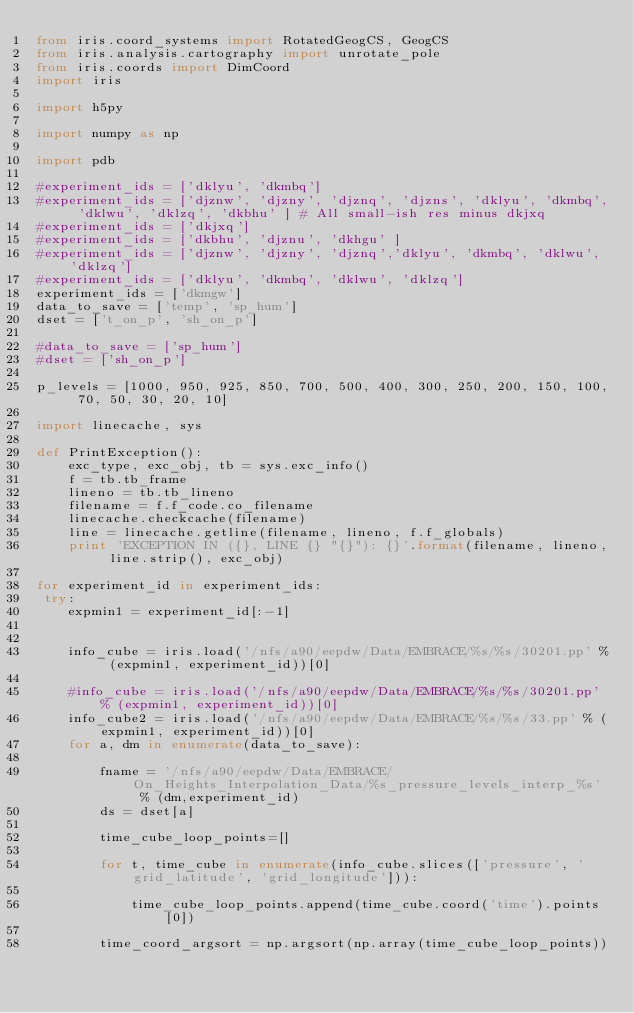<code> <loc_0><loc_0><loc_500><loc_500><_Python_>from iris.coord_systems import RotatedGeogCS, GeogCS
from iris.analysis.cartography import unrotate_pole
from iris.coords import DimCoord
import iris

import h5py

import numpy as np

import pdb

#experiment_ids = ['dklyu', 'dkmbq']
#experiment_ids = ['djznw', 'djzny', 'djznq', 'djzns', 'dklyu', 'dkmbq', 'dklwu', 'dklzq', 'dkbhu' ] # All small-ish res minus dkjxq
#experiment_ids = ['dkjxq']
#experiment_ids = ['dkbhu', 'djznu', 'dkhgu' ]
#experiment_ids = ['djznw', 'djzny', 'djznq','dklyu', 'dkmbq', 'dklwu', 'dklzq']
#experiment_ids = ['dklyu', 'dkmbq', 'dklwu', 'dklzq']
experiment_ids = ['dkmgw']
data_to_save = ['temp', 'sp_hum']
dset = ['t_on_p', 'sh_on_p']

#data_to_save = ['sp_hum']
#dset = ['sh_on_p']

p_levels = [1000, 950, 925, 850, 700, 500, 400, 300, 250, 200, 150, 100, 70, 50, 30, 20, 10]

import linecache, sys

def PrintException():
    exc_type, exc_obj, tb = sys.exc_info()
    f = tb.tb_frame
    lineno = tb.tb_lineno
    filename = f.f_code.co_filename
    linecache.checkcache(filename)
    line = linecache.getline(filename, lineno, f.f_globals)
    print 'EXCEPTION IN ({}, LINE {} "{}"): {}'.format(filename, lineno, line.strip(), exc_obj)

for experiment_id in experiment_ids:
 try:
    expmin1 = experiment_id[:-1]

   
    info_cube = iris.load('/nfs/a90/eepdw/Data/EMBRACE/%s/%s/30201.pp' % (expmin1, experiment_id))[0]

    #info_cube = iris.load('/nfs/a90/eepdw/Data/EMBRACE/%s/%s/30201.pp' % (expmin1, experiment_id))[0]
    info_cube2 = iris.load('/nfs/a90/eepdw/Data/EMBRACE/%s/%s/33.pp' % (expmin1, experiment_id))[0]
    for a, dm in enumerate(data_to_save):
    
        fname = '/nfs/a90/eepdw/Data/EMBRACE/On_Heights_Interpolation_Data/%s_pressure_levels_interp_%s' % (dm,experiment_id)
        ds = dset[a]

        time_cube_loop_points=[]

        for t, time_cube in enumerate(info_cube.slices(['pressure', 'grid_latitude', 'grid_longitude'])):
      
            time_cube_loop_points.append(time_cube.coord('time').points[0])

        time_coord_argsort = np.argsort(np.array(time_cube_loop_points))
</code> 